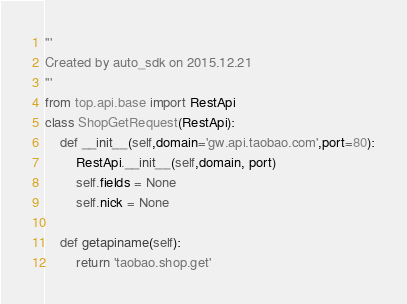<code> <loc_0><loc_0><loc_500><loc_500><_Python_>'''
Created by auto_sdk on 2015.12.21
'''
from top.api.base import RestApi
class ShopGetRequest(RestApi):
	def __init__(self,domain='gw.api.taobao.com',port=80):
		RestApi.__init__(self,domain, port)
		self.fields = None
		self.nick = None

	def getapiname(self):
		return 'taobao.shop.get'
</code> 